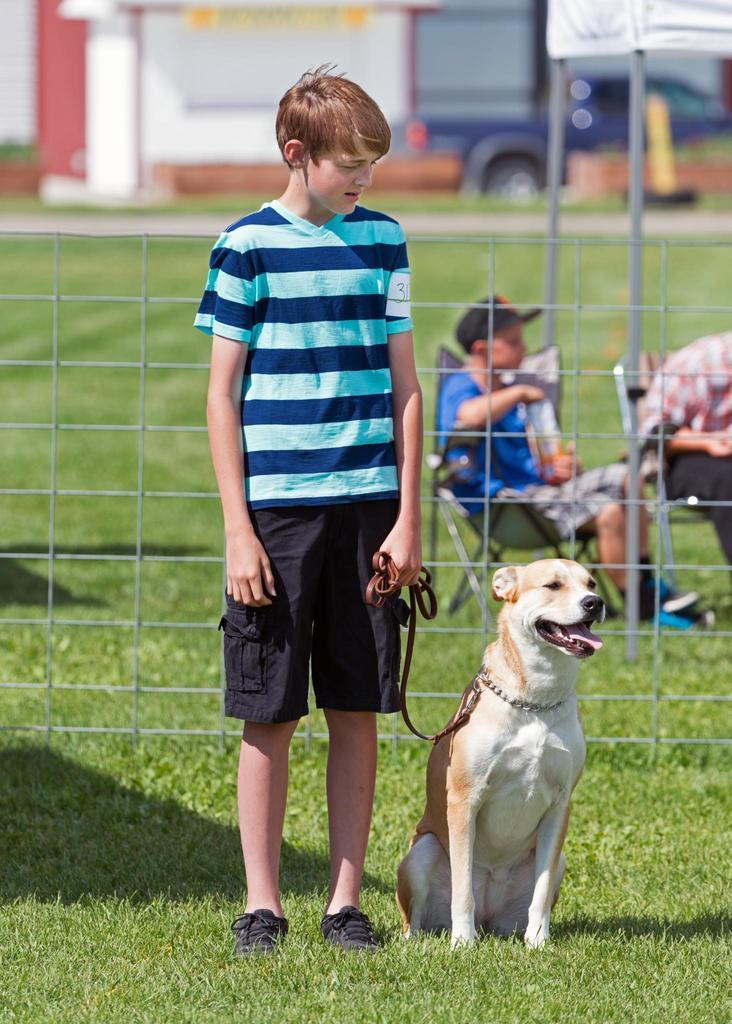What is the main subject of the image? There is a person standing in the image. Are there any animals present in the image? Yes, there is a dog in the image. How many people are sitting in the image? There are two persons sitting on chairs in the image. What type of surface is visible in the image? There is grass in the image. What type of barrier is present in the image? There is fencing in the image. How would you describe the background of the image? The background of the image is blurred. What note is the person playing on the piano in the image? There is no piano present in the image; it features a person standing, a dog, and two sitting persons. What color is the sock on the dog's paw in the image? There is no sock on the dog's paw in the image; the dog is not wearing any clothing or accessories. 